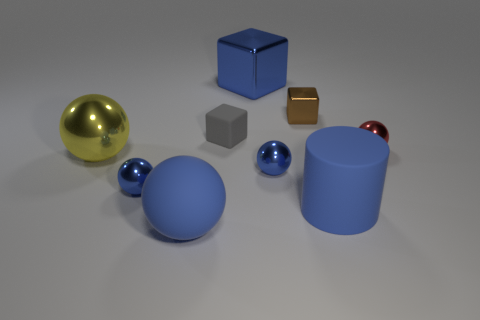Is the number of small objects less than the number of big blue matte objects?
Your answer should be very brief. No. What number of blue metallic balls have the same size as the blue cylinder?
Your answer should be very brief. 0. There is a large rubber thing that is the same color as the rubber cylinder; what is its shape?
Make the answer very short. Sphere. What is the material of the blue cylinder?
Provide a succinct answer. Rubber. There is a metal object that is right of the brown block; how big is it?
Provide a short and direct response. Small. How many other objects have the same shape as the big blue shiny thing?
Ensure brevity in your answer.  2. There is a gray thing that is the same material as the large blue sphere; what is its shape?
Your answer should be very brief. Cube. How many purple objects are either small balls or tiny blocks?
Give a very brief answer. 0. There is a small red shiny object; are there any small red metallic balls to the left of it?
Offer a very short reply. No. Do the big object behind the gray matte cube and the large matte thing behind the large blue sphere have the same shape?
Offer a very short reply. No. 